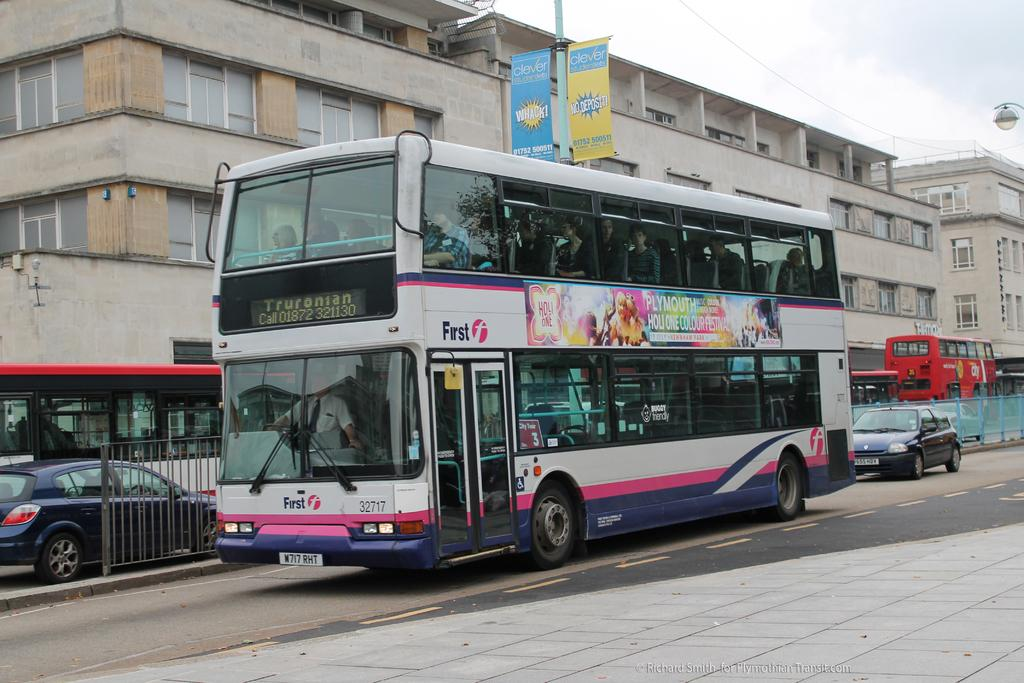<image>
Present a compact description of the photo's key features. The bus has the company name First on the side of it 